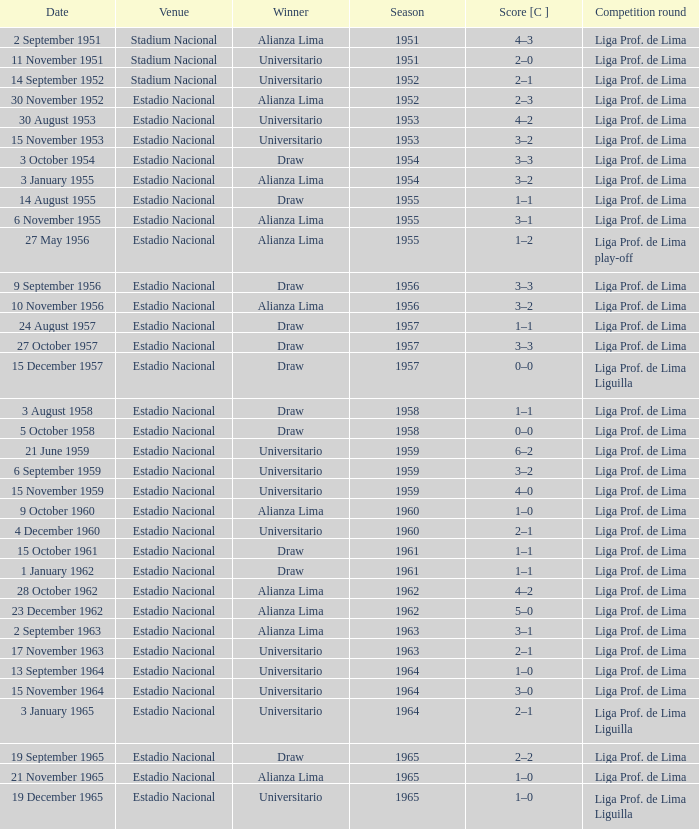What venue had an event on 17 November 1963? Estadio Nacional. 